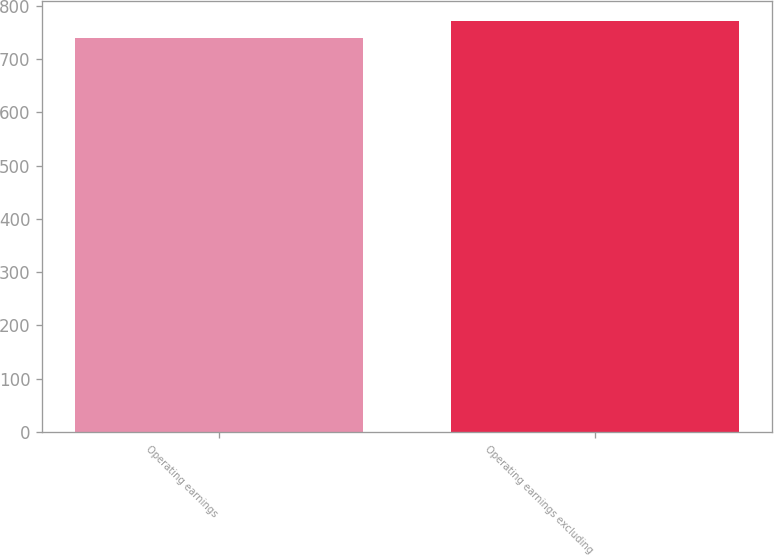<chart> <loc_0><loc_0><loc_500><loc_500><bar_chart><fcel>Operating earnings<fcel>Operating earnings excluding<nl><fcel>740<fcel>771<nl></chart> 